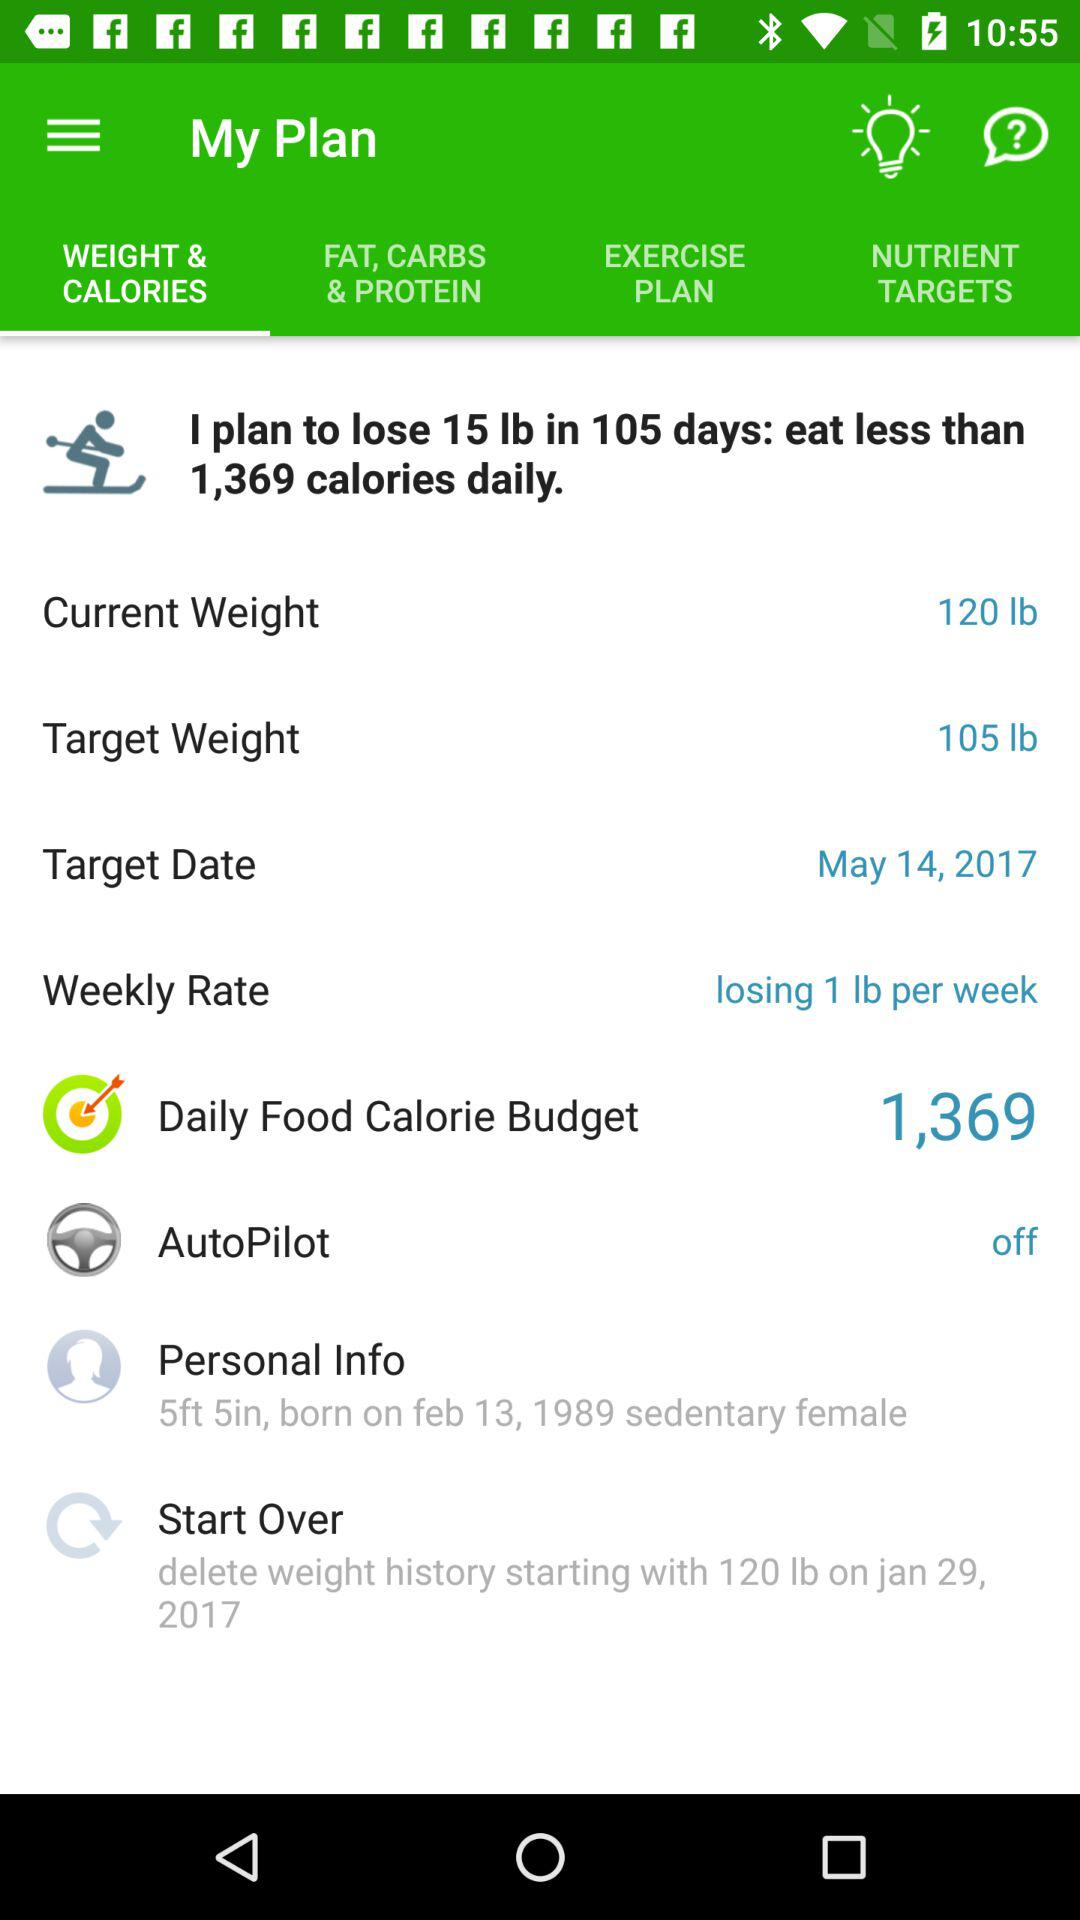What is "Target Weight"? "Target Weight" is 105 lb. 